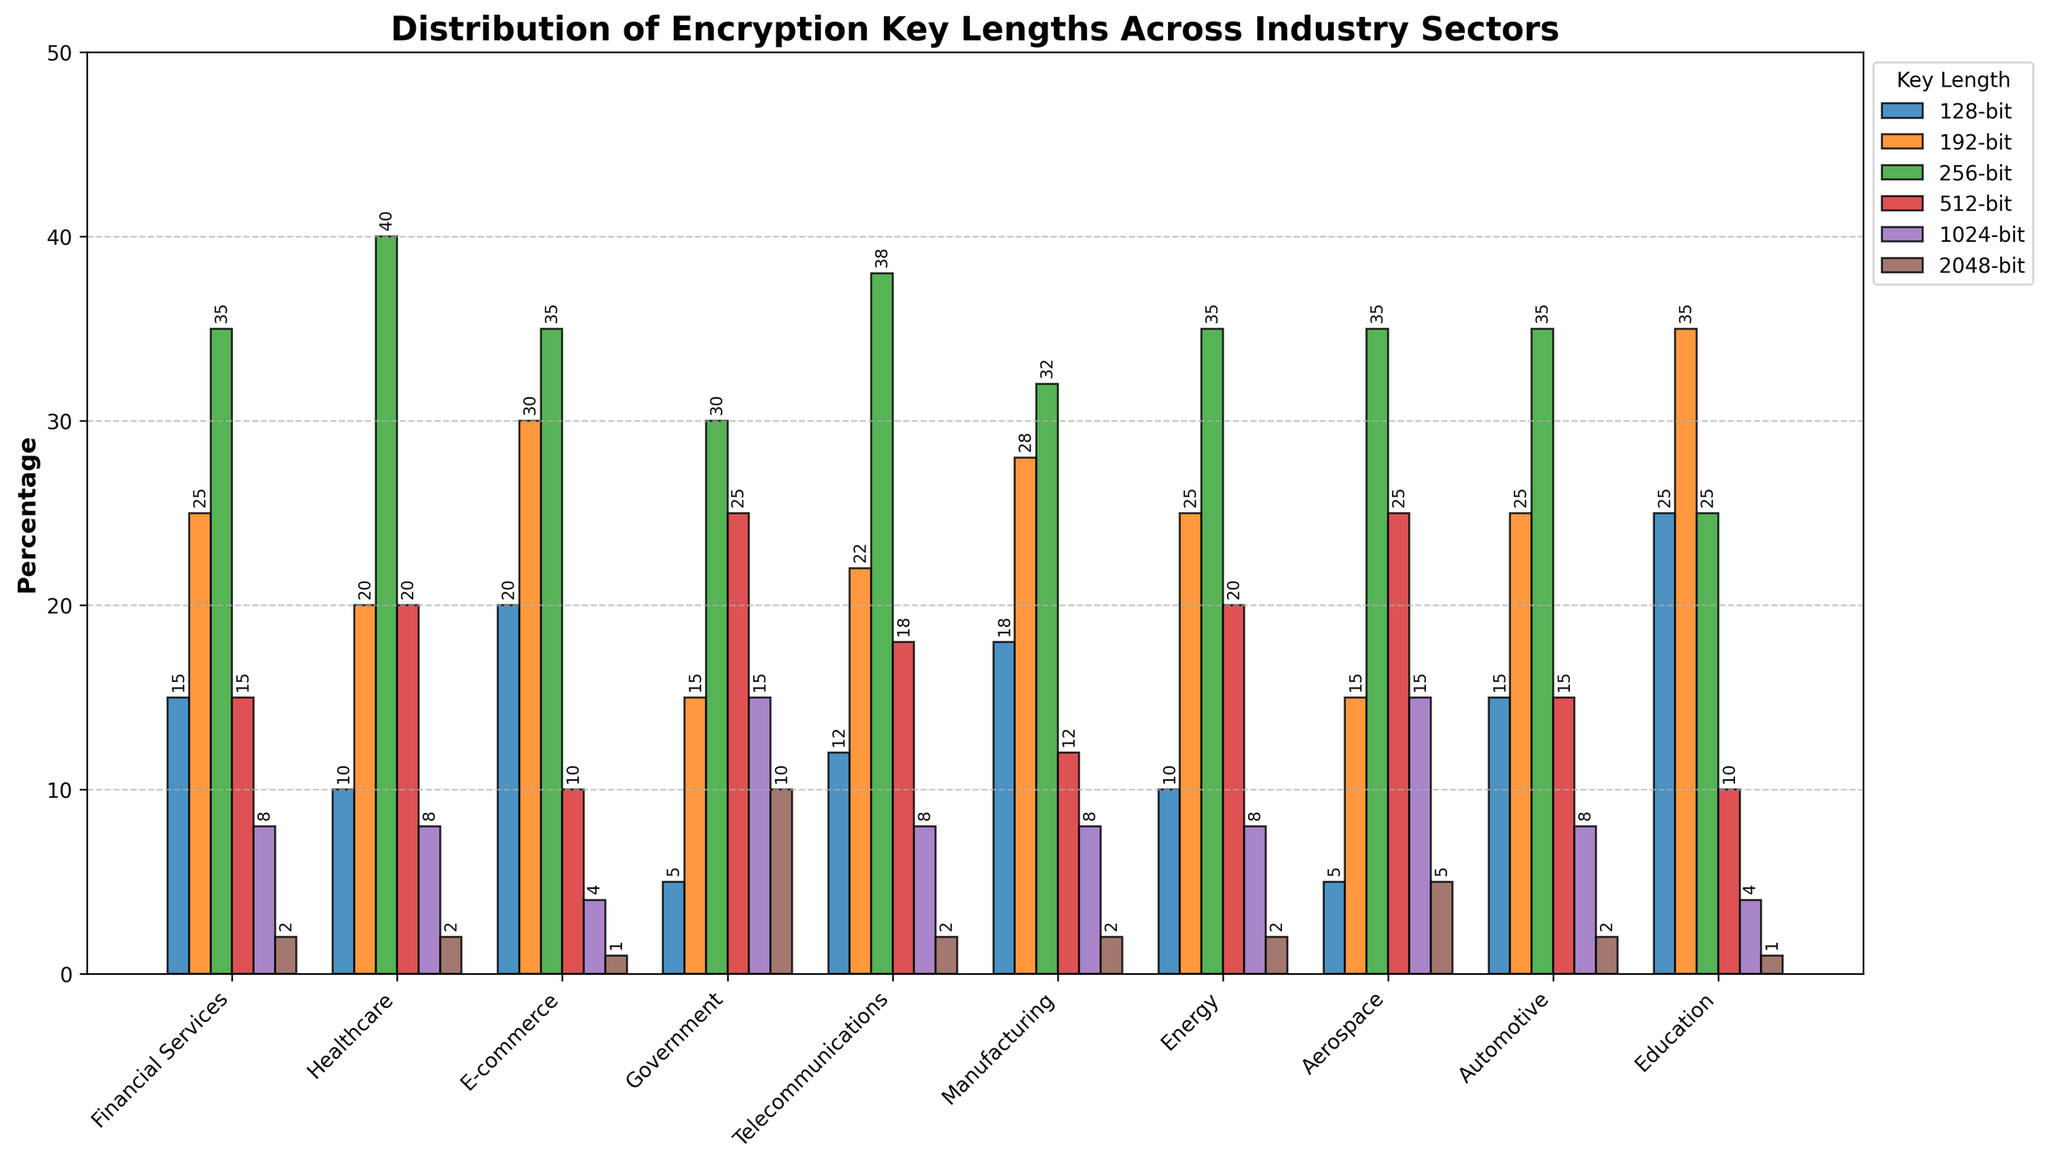Which industry sector uses 512-bit encryption keys the most? The height of the bars for 512-bit encryption in different industry sectors shows that Government and Aerospace sectors have the tallest bars. These sectors both use 512-bit encryption keys the most.
Answer: Government, Aerospace What is the total percentage of 256-bit encryption keys used in Financial Services and E-commerce sectors? Add the percentage of 256-bit encryption keys used in Financial Services (35%) and E-commerce (35%). So, 35 + 35 = 70%
Answer: 70% Which key length is used the least across all industry sectors? Compare the height of the bars for different key lengths across all industries. The 2048-bit key length usually has the shortest bar.
Answer: 2048-bit How does the usage of 128-bit keys in the Automotive sector compare to the Education sector? The bar for 128-bit keys in the Automotive sector is shorter compared to the bar in the Education sector. This means the Automotive sector uses fewer 128-bit keys than the Education sector.
Answer: Less Which sector has the highest usage of 1024-bit encryption keys? Look for the sector with the tallest bar for 1024-bit encryption. The Government and Aerospace sectors have the highest bars, tied for the usage of 1024-bit encryption keys.
Answer: Government, Aerospace What is the average percentage of 192-bit encryption keys used in Telecommunications and Energy sectors? Find the values for 192-bit encryption keys in Telecommunications (22%) and Energy (25%), then calculate the average: (22 + 25) / 2 = 23.5%
Answer: 23.5% Is the percentage of 192-bit keys used in Healthcare greater than the percentage used in Financial Services? Compare the heights of the bars for 192-bit keys in both sectors. Both sectors have the same height bars for 192-bit keys at 25%.
Answer: No, they are equal In which sector is the usage of 256-bit encryption keys exactly the same as the 128-bit keys? By inspecting the bars for 256-bit and 128-bit keys across all sectors, note that no sector has equal heights for 256-bit and 128-bit keys.
Answer: None What is the combined percentage usage of 256-bit and 192-bit keys in the Manufacturing sector? The bars for 256-bit and 192-bit keys in the Manufacturing sector are 32% and 28%, respectively. Add these percentages: 32 + 28 = 60%
Answer: 60% Which key length shows the most balanced usage across all sectors? By considering all bars across sectors and identifying the key length where the heights do not vary widely, 256-bit keys show the most balanced usage.
Answer: 256-bit 